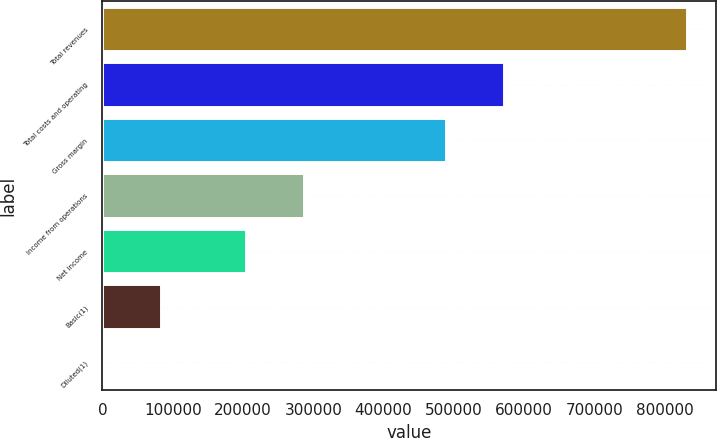<chart> <loc_0><loc_0><loc_500><loc_500><bar_chart><fcel>Total revenues<fcel>Total costs and operating<fcel>Gross margin<fcel>Income from operations<fcel>Net income<fcel>Basic(1)<fcel>Diluted(1)<nl><fcel>831599<fcel>571933<fcel>488773<fcel>286741<fcel>203581<fcel>83161<fcel>1.21<nl></chart> 